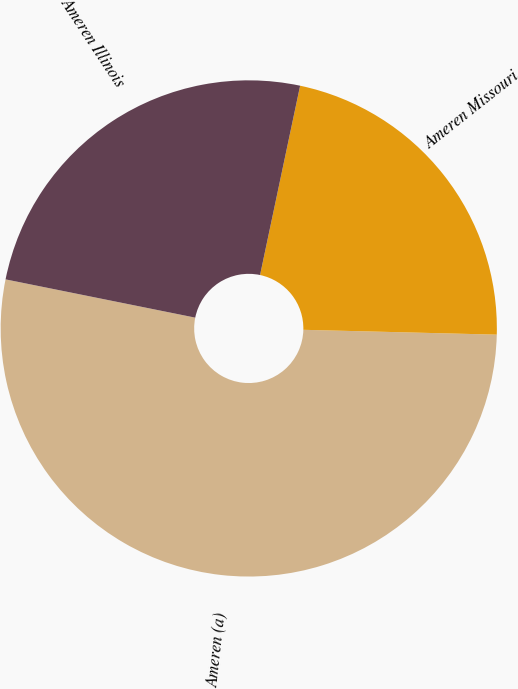<chart> <loc_0><loc_0><loc_500><loc_500><pie_chart><fcel>Ameren (a)<fcel>Ameren Missouri<fcel>Ameren Illinois<nl><fcel>52.77%<fcel>22.08%<fcel>25.15%<nl></chart> 